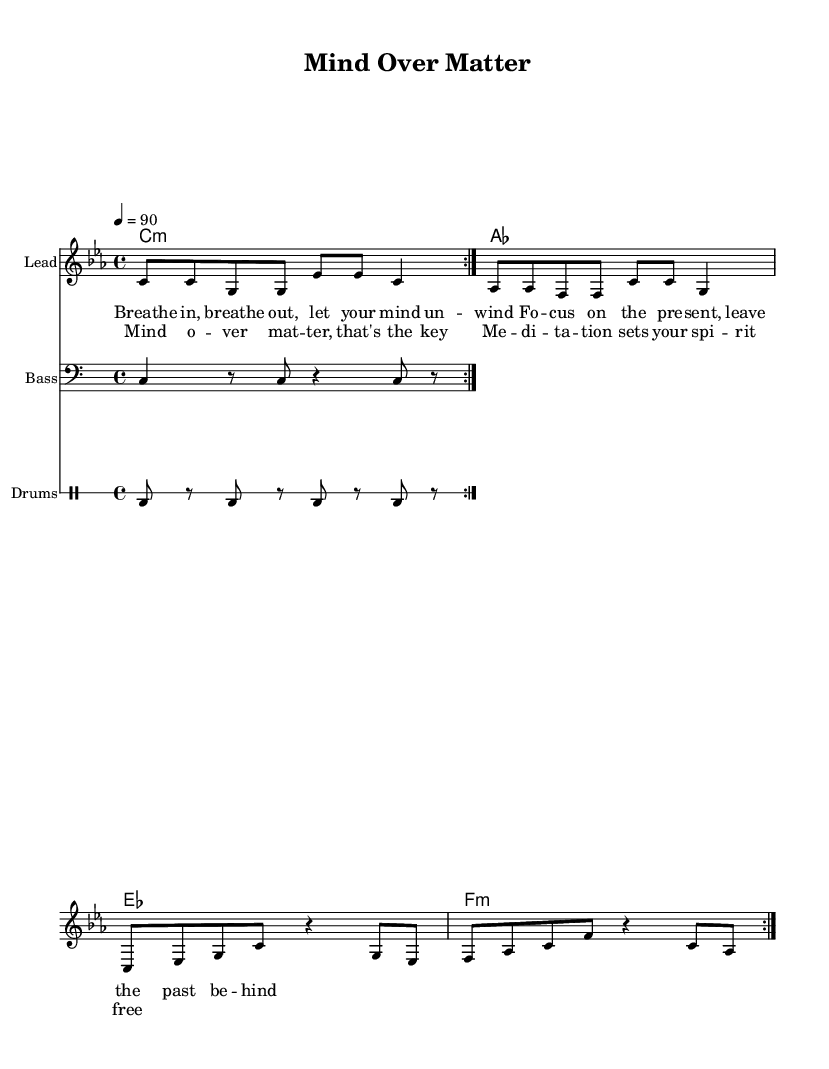What is the key signature of this music? The key signature is C minor, which has three flats (B♭, E♭, A♭).
Answer: C minor What is the time signature of this music? The time signature is 4/4, which means there are four beats in each measure.
Answer: 4/4 What is the tempo marking for this piece? The tempo marking is 90 beats per minute, indicated by the tempo of "4 = 90."
Answer: 90 How many measures does the melody repeat? The melody repeats twice, indicated by the "repeat volta 2" marking.
Answer: 2 What type of drum pattern is used in this piece? The drum pattern consists of bass drums, indicated by the repeated "bd" symbols in the drum notation.
Answer: Bass drum What is the message conveyed in the chorus lyrics? The chorus mentions "Mind over matter," emphasizing the theme of meditation and its liberating effects on the spirit.
Answer: Meditation sets your spirit free What is the overall thematic focus of this rap piece? The overall thematic focus centers on mindfulness and the benefits of meditation, as shown through the lyrics and title.
Answer: Mindfulness 